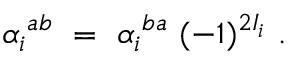<formula> <loc_0><loc_0><loc_500><loc_500>{ \alpha _ { i } } ^ { a b } \ = \ { \alpha _ { i } } ^ { b a } \ ( - 1 ) ^ { 2 I _ { i } } \ .</formula> 